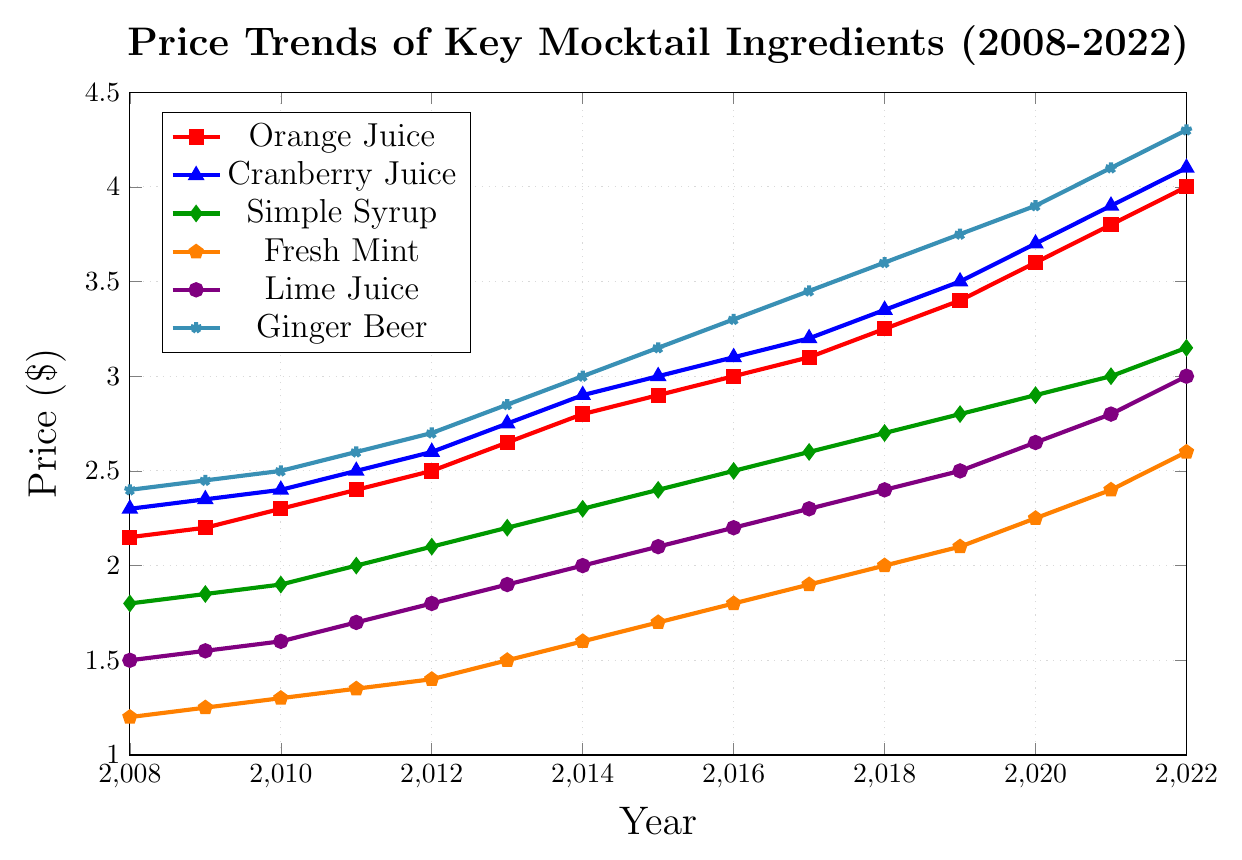What's the trend in the price of Orange Juice from 2008 to 2022? The trend in the price of Orange Juice shows a steady increase from $2.15 in 2008 to $4.00 in 2022. This gradual upward trend suggests growing costs over the years.
Answer: Steady increase Which ingredient had the highest price in 2022 based on the chart? In 2022, Ginger Beer had the highest price at $4.30, as indicated by the highest point on the chart.
Answer: Ginger Beer How much did the price of Simple Syrup increase from 2010 to 2020? In 2010, the price of Simple Syrup was $1.90, and in 2020 it was $2.90. The increase can be calculated as $2.90 - $1.90 = $1.00.
Answer: $1.00 Compare the prices of Cranberry Juice and Lime Juice in 2015. Which one was higher and by how much? In 2015, Cranberry Juice was priced at $3.00, while Lime Juice was $2.10. Cranberry Juice was higher by $3.00 - $2.10 = $0.90.
Answer: Cranberry Juice by $0.90 What is the average price of Fresh Mint over the 15-year period? The prices of Fresh Mint from 2008 to 2022 are: $1.20, $1.25, $1.30, $1.35, $1.40, $1.50, $1.60, $1.70, $1.80, $1.90, $2.00, $2.10, $2.25, $2.40, $2.60. Summing these gives $26.35, and the average over 15 years is $26.35 / 15 = $1.76.
Answer: $1.76 Between 2018 and 2022, which ingredient had the largest price increase? From 2018 to 2022, Ginger Beer increased from $3.60 to $4.30, an increase of $0.70. Comparatively, the price increases for other ingredients in the same period were lower, making Ginger Beer the one with the largest increase.
Answer: Ginger Beer How did the price of Fresh Mint change from 2011 to 2021? The price of Fresh Mint increased steadily from $1.35 in 2011 to $2.40 in 2021. This shows a total increase of $2.40 - $1.35 = $1.05 over the decade.
Answer: Increased by $1.05 Which ingredient saw the least price increase from 2008 to 2022? Fresh Mint saw the least price increase from $1.20 in 2008 to $2.60 in 2022, an increase of $1.40. Relative to other ingredients that increased more significantly, Fresh Mint had the smallest overall increase.
Answer: Fresh Mint What is the difference in price between Cranberry Juice and Orange Juice in 2022? In 2022, Cranberry Juice was priced at $4.10, while Orange Juice was priced at $4.00. The difference is $4.10 - $4.00 = $0.10.
Answer: $0.10 Between 2013 and 2017, which ingredient showed a continuous annual price increase? Between 2013 and 2017, all ingredients show a continuous annual price increase without any year of price decrease. However, a clear standout is Orange Juice with visible steady increments every year in the given period.
Answer: Orange Juice 